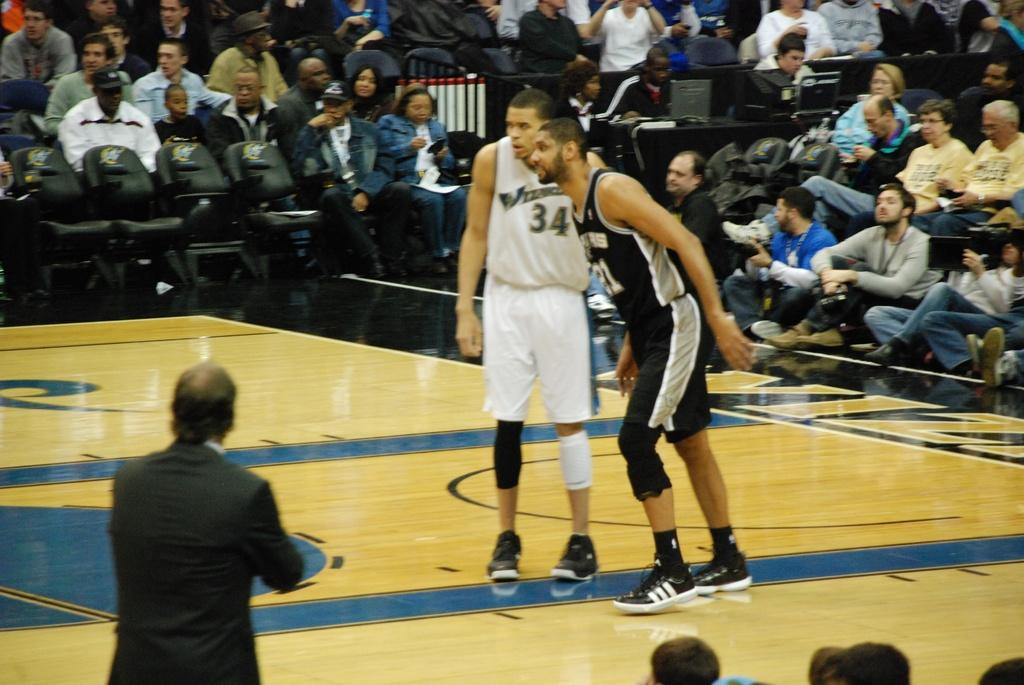How many people are visible in the image? There are two people standing in the image. What are the people in the background doing? In the background, there are people sitting on chairs. Where is the butter stored in the image? There is no butter present in the image. 